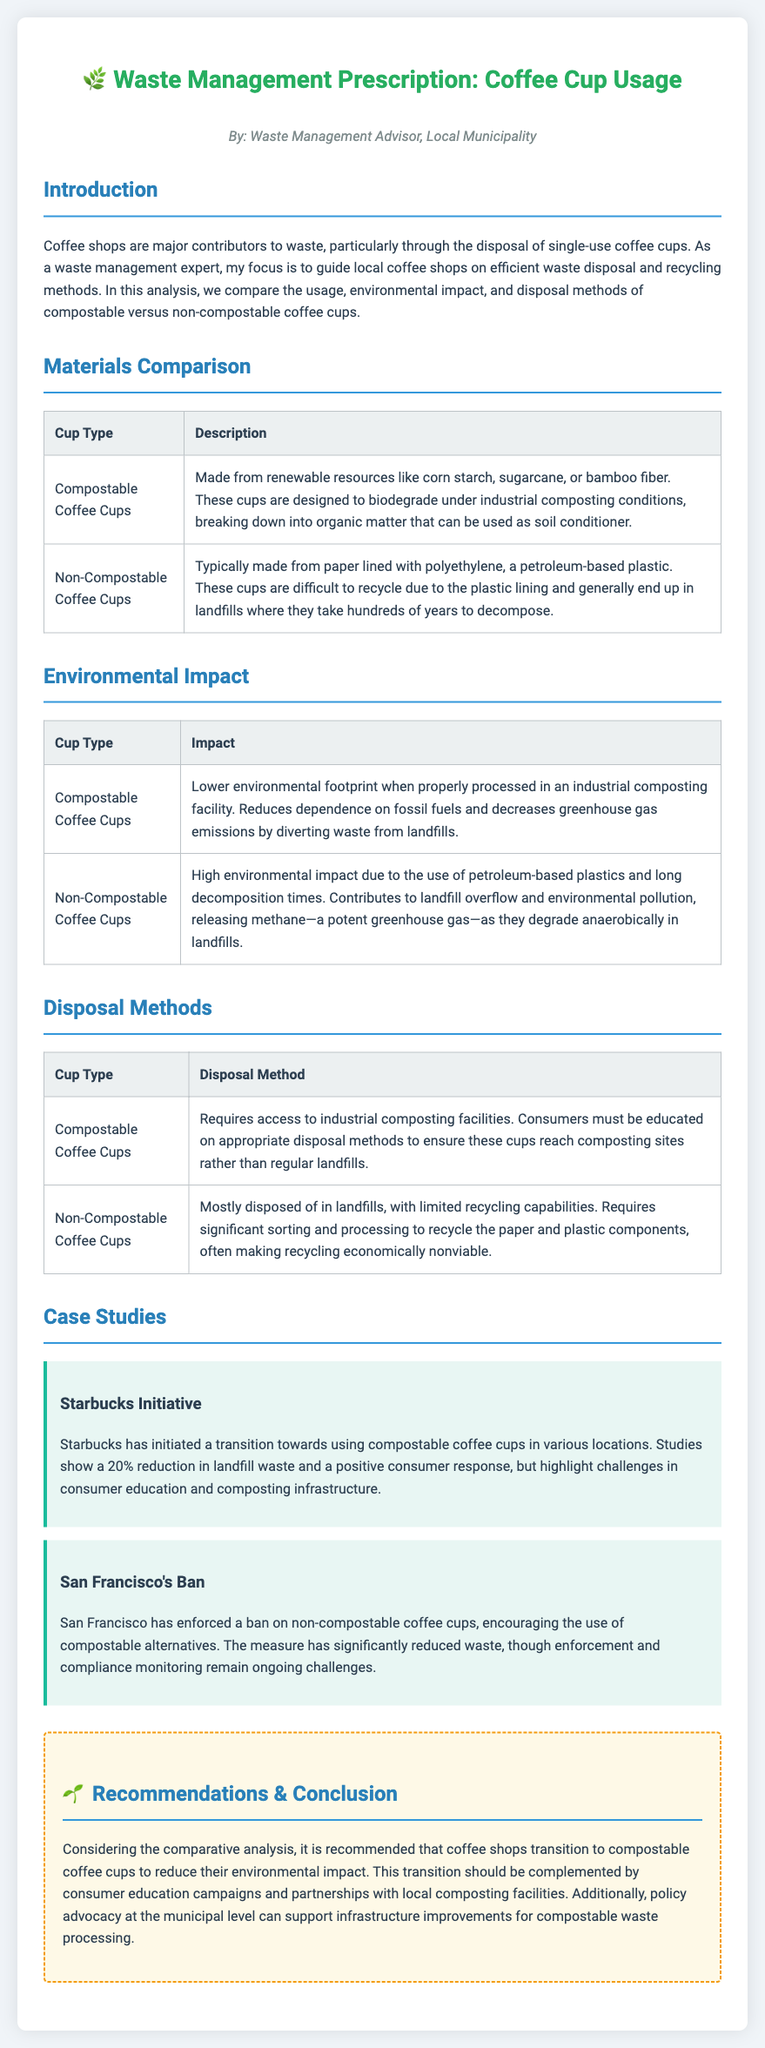What is the primary focus of the document? The primary focus is to guide local coffee shops on efficient waste disposal and recycling methods.
Answer: Efficient waste disposal and recycling methods What materials are used for compostable coffee cups? Compostable coffee cups are made from renewable resources like corn starch, sugarcane, or bamboo fiber.
Answer: Renewable resources like corn starch, sugarcane, or bamboo fiber What is the environmental impact of non-compostable coffee cups? Non-compostable coffee cups have a high environmental impact due to the use of petroleum-based plastics and long decomposition times.
Answer: High environmental impact What is the recommended disposal method for compostable coffee cups? Compostable coffee cups require access to industrial composting facilities.
Answer: Industrial composting facilities Which city enforced a ban on non-compostable coffee cups? San Francisco enforced a ban on non-compostable coffee cups.
Answer: San Francisco How much reduction in landfill waste did Starbucks achieve with compostable cups? Starbucks achieved a 20% reduction in landfill waste.
Answer: 20% What policy advocacy is recommended for compostable waste processing? Policy advocacy at the municipal level can support infrastructure improvements for compostable waste processing.
Answer: Municipal level What type of document is this? This document is a prescription regarding waste management.
Answer: Prescription 